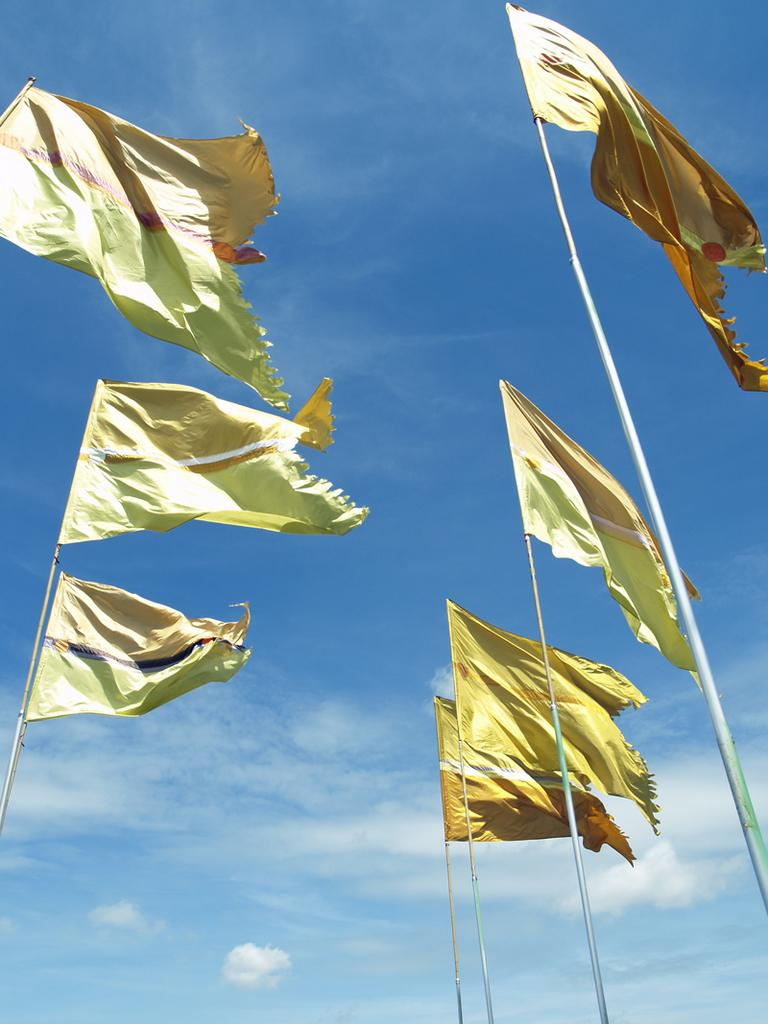What objects are present in the image that represent a country or organization? There are flags in the image. How are the flags displayed in the image? The flags are attached to flag posts. What can be seen in the background of the image? The sky is visible in the background of the image. What type of feast is being prepared in the image? There is no indication of a feast or any food preparation in the image; it only features flags and flag posts. 